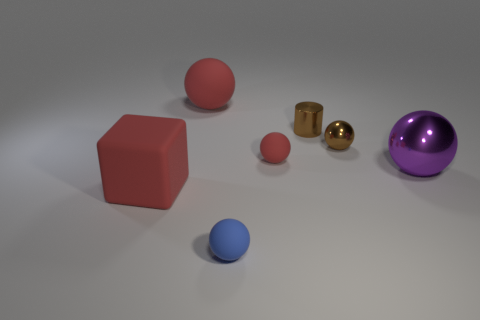What is the shape of the small red object?
Provide a short and direct response. Sphere. How many other things are there of the same shape as the blue object?
Keep it short and to the point. 4. There is a small rubber thing to the right of the blue object; what is its color?
Make the answer very short. Red. Is the material of the cube the same as the large red sphere?
Your answer should be very brief. Yes. What number of things are either small blue matte spheres or rubber things that are in front of the large purple ball?
Offer a terse response. 2. The shiny object that is the same color as the metal cylinder is what size?
Offer a terse response. Small. The small matte thing that is behind the tiny blue rubber sphere has what shape?
Your answer should be compact. Sphere. Do the tiny shiny object that is to the right of the small brown metallic cylinder and the matte cube have the same color?
Ensure brevity in your answer.  No. What material is the tiny thing that is the same color as the tiny metal ball?
Make the answer very short. Metal. There is a thing that is on the right side of the brown sphere; does it have the same size as the tiny shiny cylinder?
Your response must be concise. No. 